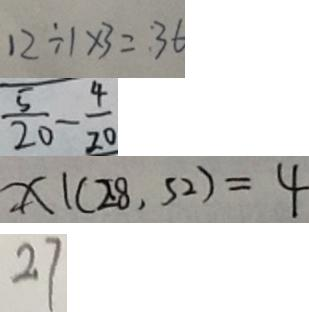Convert formula to latex. <formula><loc_0><loc_0><loc_500><loc_500>1 2 \div 1 \times 3 = : 3 6 
 \frac { 5 } { 2 0 } - \frac { 4 } { 2 0 } 
 X \vert ( 2 8 , 5 2 ) = 4 
 2 7</formula> 